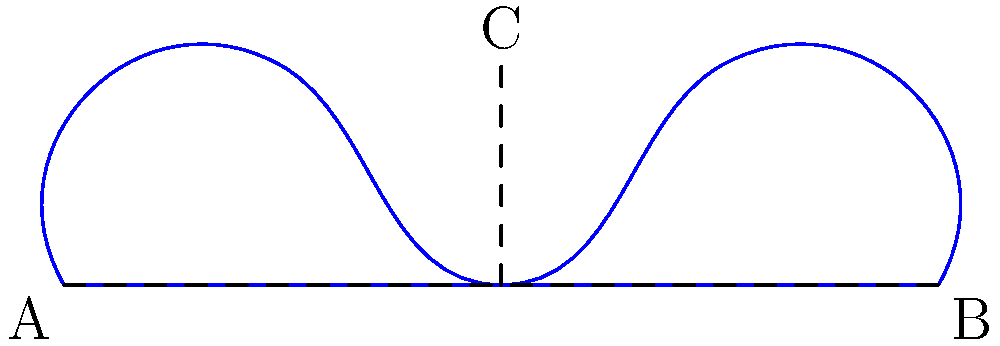Check out this paper cutout of a hip-hop artist's silhouette. If you fold it in half along the center line, how many times will the folded edge touch the outline? Let's break this down step by step:

1. The silhouette is symmetric, with the center line running from point C to the midpoint of AB.

2. When folded, the left half will overlap the right half perfectly.

3. We need to count the number of times the folded edge (which is the center line) intersects the outline of the silhouette.

4. Starting from the top:
   - It touches at point C
   - It intersects the curve once between C and the base
   - It touches at the base (midpoint of AB)

5. Total count: The folded edge touches the outline 3 times.
Answer: 3 times 